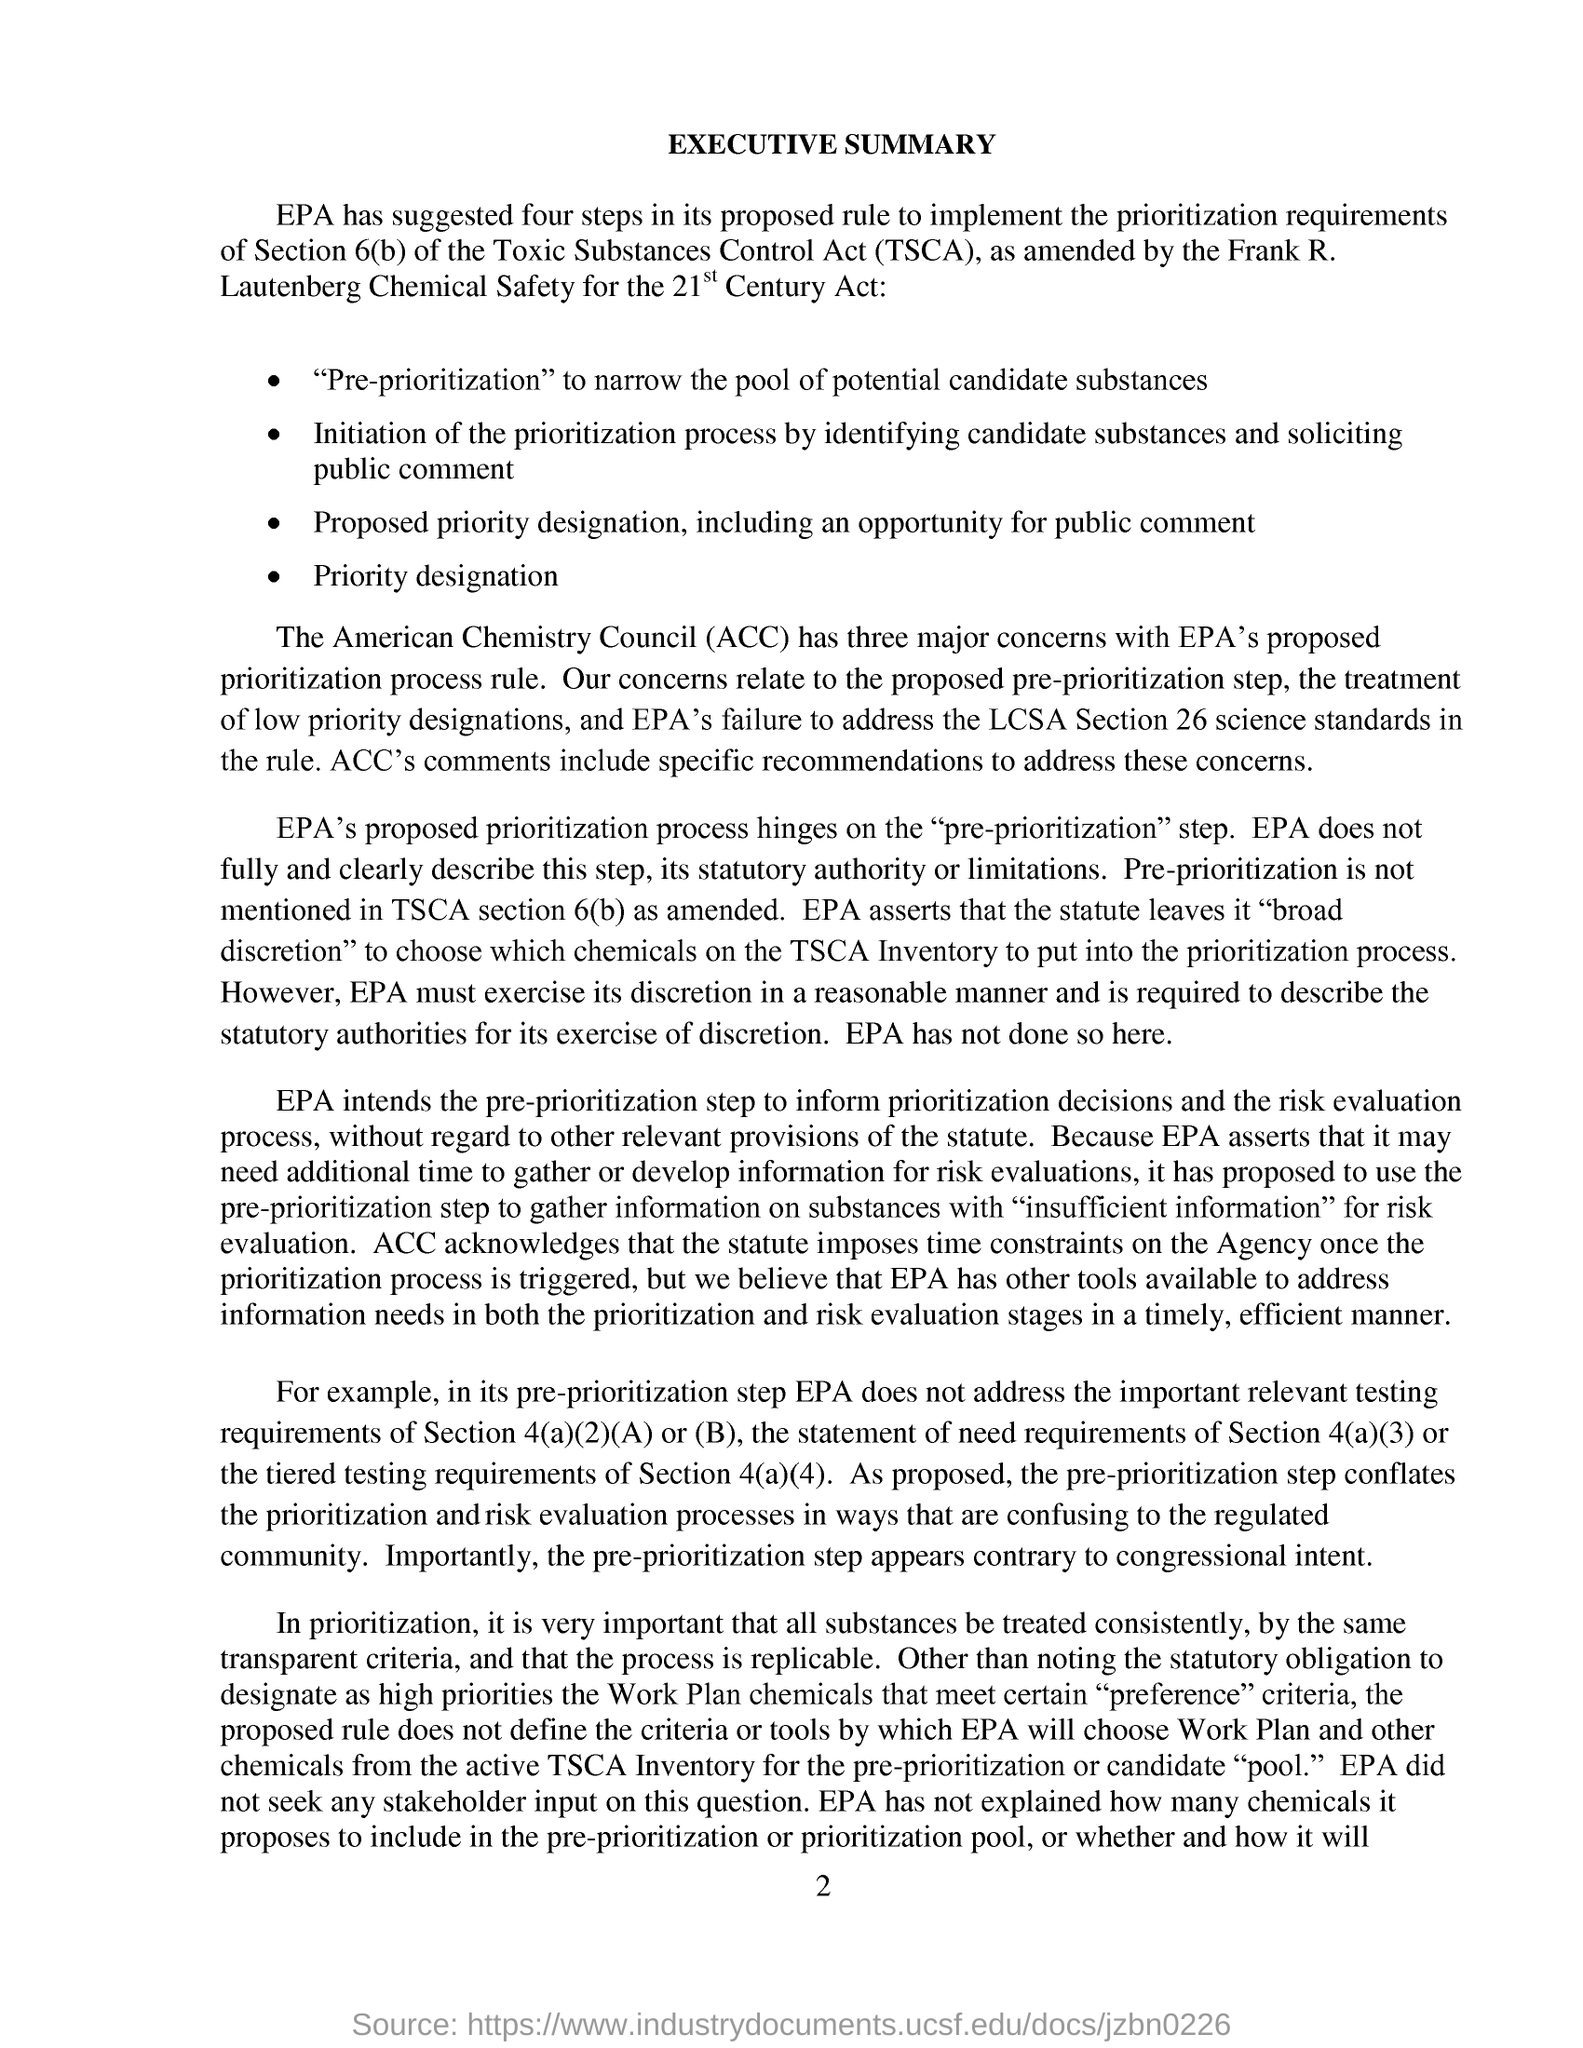Outline some significant characteristics in this image. According to the proposed rule by the EPA, four steps have been suggested. The abbreviation of 'Toxic Substances Control Act' is TSCA. The fourth step proposed by the EPA in its rule is priority designation. The document heading is "What is the document heading?" and the executive summary follows. The page number given at the footer of the document is 2. 